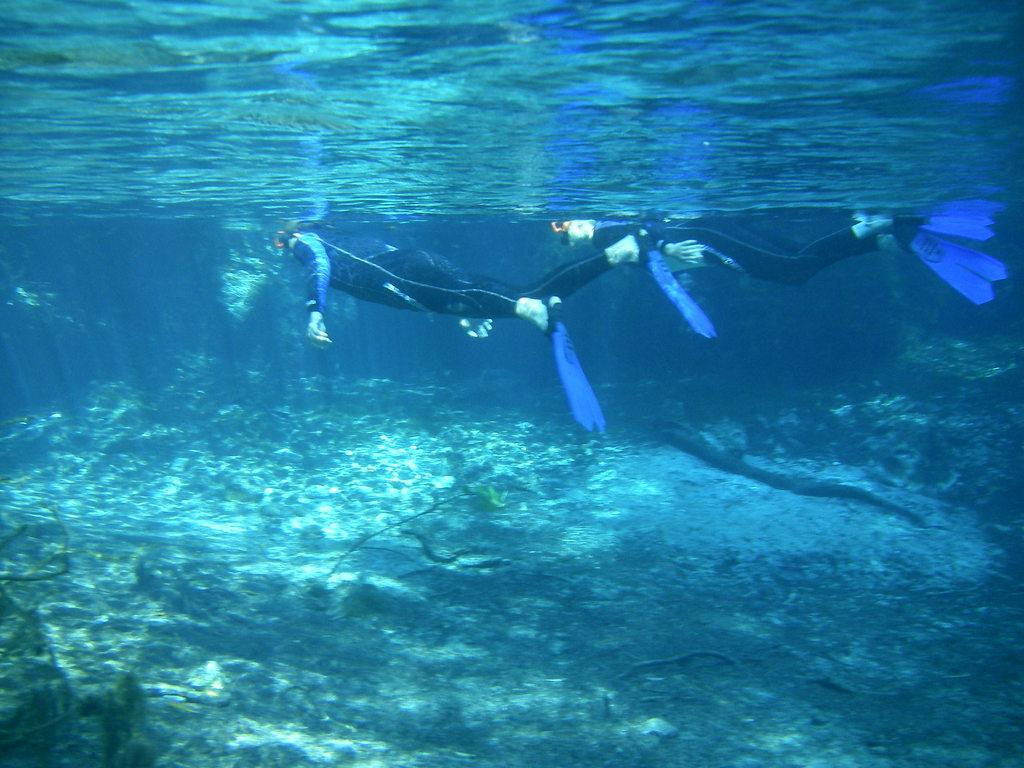How many people are in the image? There are two persons in the image. What are the two persons doing in the image? The two persons are swimming inside the water. What color are the dresses worn by the persons in the image? The persons are wearing black color dresses. What type of clouds can be seen in the image? There are no clouds visible in the image, as it features two persons swimming inside the water. What song is being sung by the persons in the image? There is no indication in the image that the persons are singing a song. 